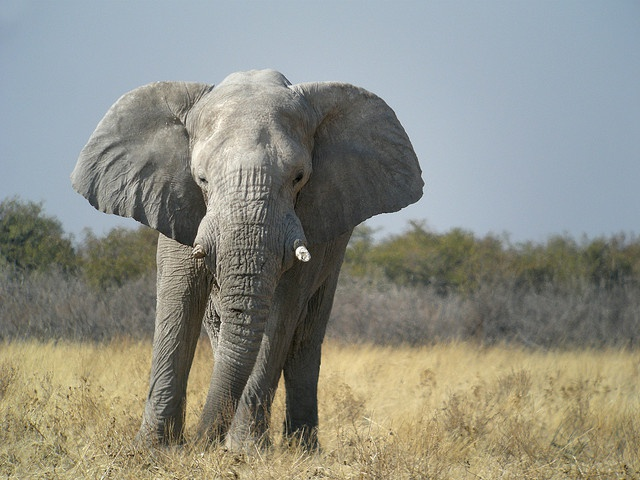Describe the objects in this image and their specific colors. I can see a elephant in darkgray, gray, and black tones in this image. 